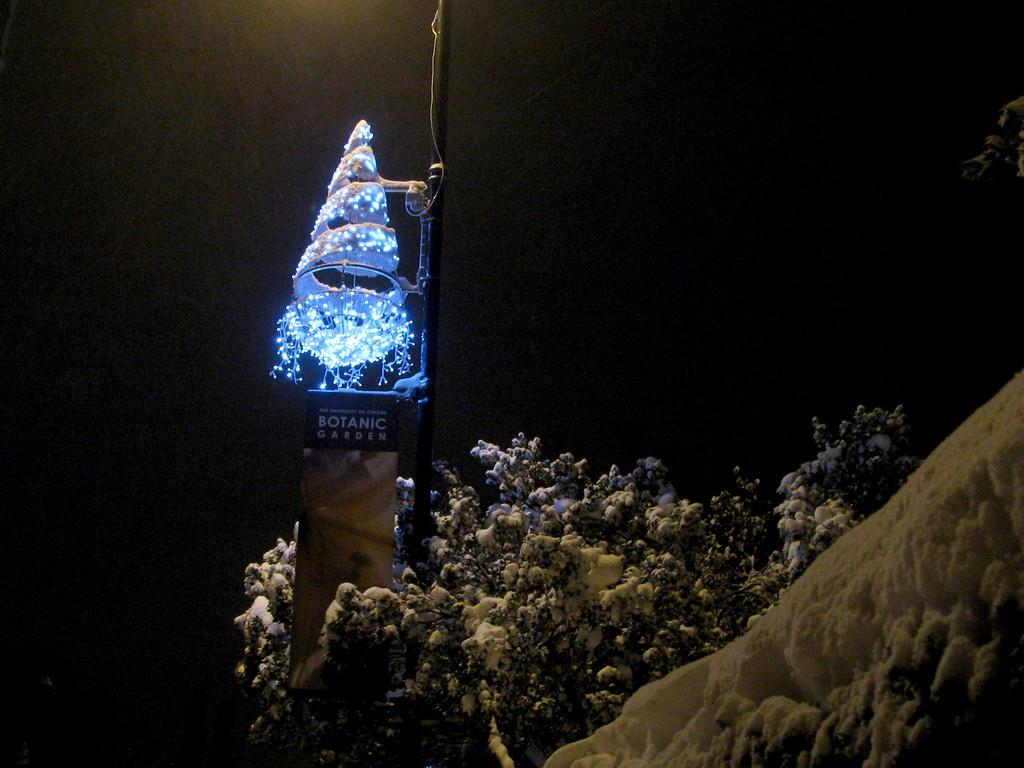What type of living organisms can be seen in the image? Plants can be seen in the image. What else is present in the image besides the plants? There is a board with text in the image, and the board has a tree with lights on top of it. What type of ring is your aunt wearing in the image? There is no aunt or ring present in the image; it only features plants, a board with text, and a tree with lights. 